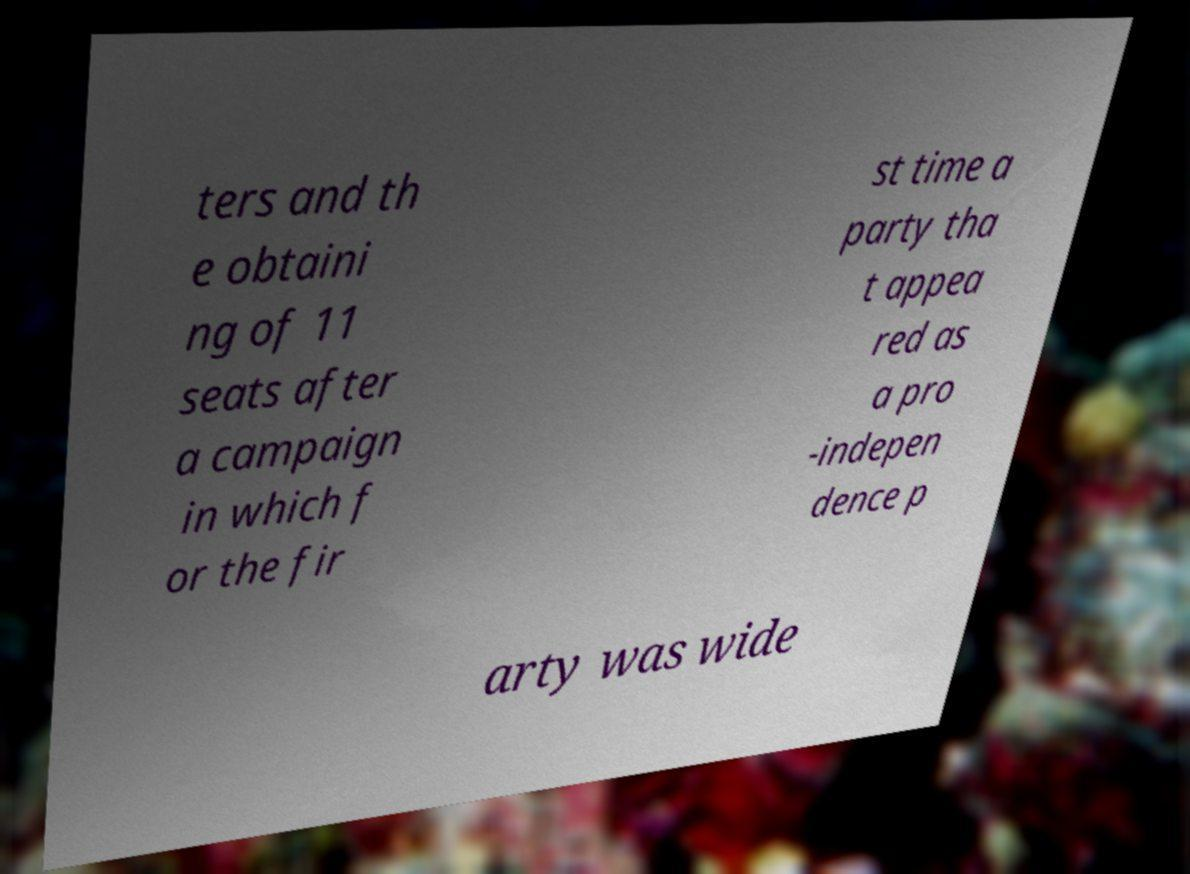Could you extract and type out the text from this image? ters and th e obtaini ng of 11 seats after a campaign in which f or the fir st time a party tha t appea red as a pro -indepen dence p arty was wide 